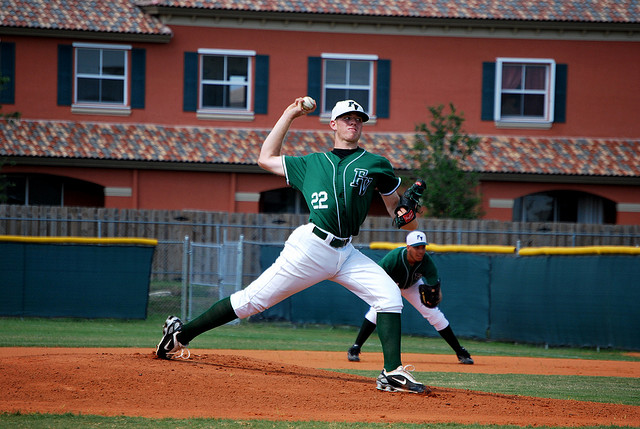<image>What ballpark are they playing in? I am not sure the ballpark they are playing in. It is either 'florida', 'fenway', 'baseball field', 'park', 'baseball' or 'neighborhood'. What ballpark are they playing in? It is ambiguous what ballpark they are playing in. It can be 'fenway' or any other baseball field. 